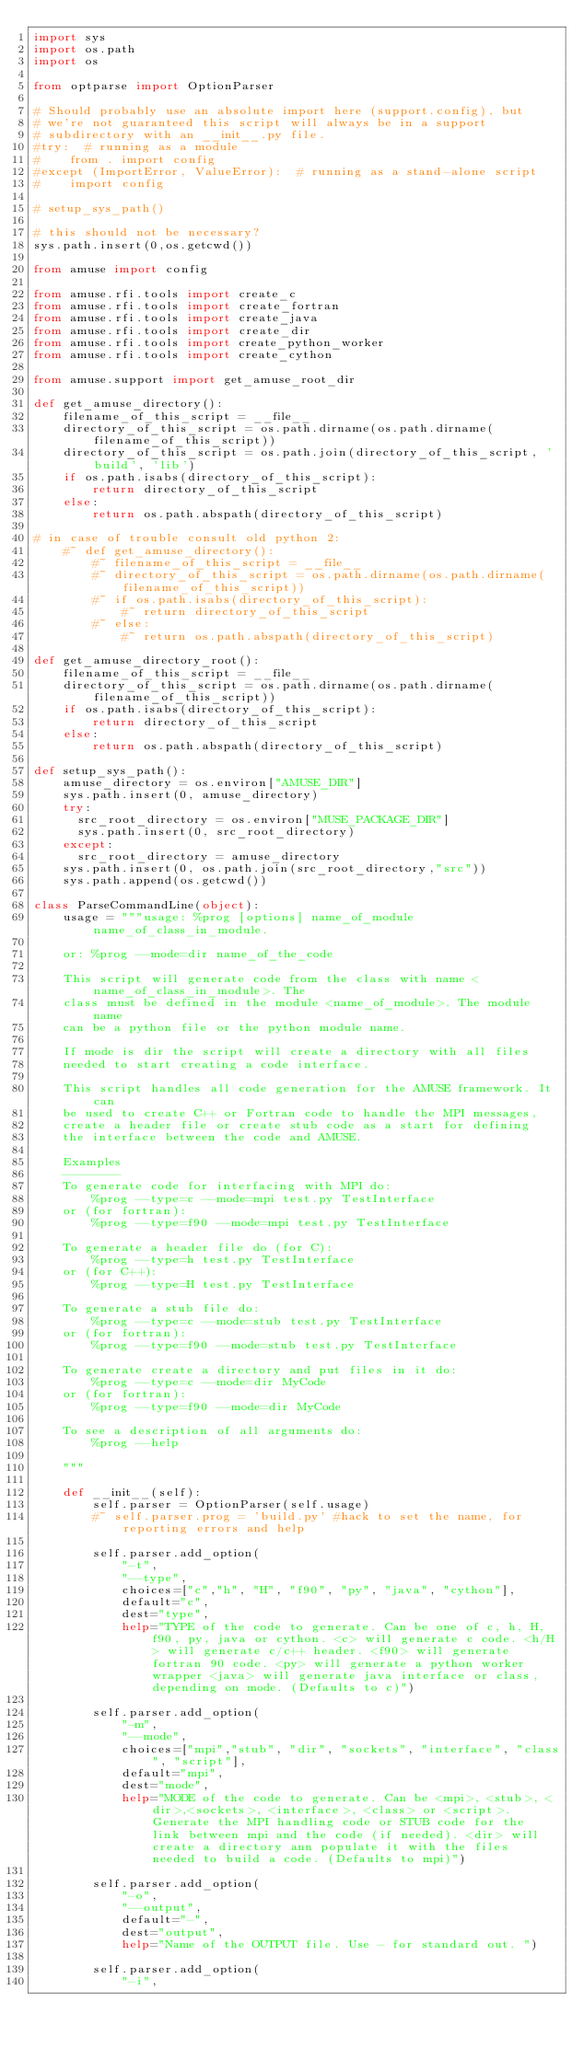Convert code to text. <code><loc_0><loc_0><loc_500><loc_500><_Python_>import sys
import os.path
import os

from optparse import OptionParser

# Should probably use an absolute import here (support.config), but
# we're not guaranteed this script will always be in a support
# subdirectory with an __init__.py file.
#try:  # running as a module
#    from . import config
#except (ImportError, ValueError):  # running as a stand-alone script
#    import config

# setup_sys_path()

# this should not be necessary?
sys.path.insert(0,os.getcwd())

from amuse import config

from amuse.rfi.tools import create_c
from amuse.rfi.tools import create_fortran
from amuse.rfi.tools import create_java
from amuse.rfi.tools import create_dir
from amuse.rfi.tools import create_python_worker
from amuse.rfi.tools import create_cython
    
from amuse.support import get_amuse_root_dir    

def get_amuse_directory():
    filename_of_this_script = __file__
    directory_of_this_script = os.path.dirname(os.path.dirname(filename_of_this_script))
    directory_of_this_script = os.path.join(directory_of_this_script, 'build', 'lib')
    if os.path.isabs(directory_of_this_script):
        return directory_of_this_script
    else:
        return os.path.abspath(directory_of_this_script)

# in case of trouble consult old python 2:     
    #~ def get_amuse_directory():
        #~ filename_of_this_script = __file__
        #~ directory_of_this_script = os.path.dirname(os.path.dirname(filename_of_this_script))
        #~ if os.path.isabs(directory_of_this_script):
            #~ return directory_of_this_script
        #~ else:
            #~ return os.path.abspath(directory_of_this_script)

def get_amuse_directory_root():
    filename_of_this_script = __file__
    directory_of_this_script = os.path.dirname(os.path.dirname(filename_of_this_script))
    if os.path.isabs(directory_of_this_script):
        return directory_of_this_script
    else:
        return os.path.abspath(directory_of_this_script)

def setup_sys_path():
    amuse_directory = os.environ["AMUSE_DIR"]
    sys.path.insert(0, amuse_directory)
    try:
      src_root_directory = os.environ["MUSE_PACKAGE_DIR"]
      sys.path.insert(0, src_root_directory)
    except:
      src_root_directory = amuse_directory
    sys.path.insert(0, os.path.join(src_root_directory,"src"))
    sys.path.append(os.getcwd())

class ParseCommandLine(object):
    usage = """usage: %prog [options] name_of_module name_of_class_in_module.
    
    or: %prog --mode=dir name_of_the_code
    
    This script will generate code from the class with name <name_of_class_in_module>. The
    class must be defined in the module <name_of_module>. The module name
    can be a python file or the python module name.
    
    If mode is dir the script will create a directory with all files
    needed to start creating a code interface.
    
    This script handles all code generation for the AMUSE framework. It can
    be used to create C++ or Fortran code to handle the MPI messages, 
    create a header file or create stub code as a start for defining
    the interface between the code and AMUSE.
    
    Examples
    --------
    To generate code for interfacing with MPI do:
        %prog --type=c --mode=mpi test.py TestInterface
    or (for fortran):
        %prog --type=f90 --mode=mpi test.py TestInterface
        
    To generate a header file do (for C):
        %prog --type=h test.py TestInterface
    or (for C++):
        %prog --type=H test.py TestInterface
        
    To generate a stub file do:
        %prog --type=c --mode=stub test.py TestInterface
    or (for fortran):
        %prog --type=f90 --mode=stub test.py TestInterface
        
    To generate create a directory and put files in it do:
        %prog --type=c --mode=dir MyCode
    or (for fortran):
        %prog --type=f90 --mode=dir MyCode
    
    To see a description of all arguments do:
        %prog --help
    
    """
    
    def __init__(self):
        self.parser = OptionParser(self.usage)
        #~ self.parser.prog = 'build.py' #hack to set the name, for reporting errors and help
        
        self.parser.add_option(
            "-t",
            "--type",
            choices=["c","h", "H", "f90", "py", "java", "cython"],
            default="c",
            dest="type",
            help="TYPE of the code to generate. Can be one of c, h, H, f90, py, java or cython. <c> will generate c code. <h/H> will generate c/c++ header. <f90> will generate fortran 90 code. <py> will generate a python worker wrapper <java> will generate java interface or class, depending on mode. (Defaults to c)")
        
        self.parser.add_option(
            "-m",
            "--mode",
            choices=["mpi","stub", "dir", "sockets", "interface", "class", "script"],
            default="mpi",
            dest="mode",
            help="MODE of the code to generate. Can be <mpi>, <stub>, <dir>,<sockets>, <interface>, <class> or <script>. Generate the MPI handling code or STUB code for the link between mpi and the code (if needed). <dir> will create a directory ann populate it with the files needed to build a code. (Defaults to mpi)")
        
        self.parser.add_option(
            "-o",
            "--output",
            default="-",
            dest="output",
            help="Name of the OUTPUT file. Use - for standard out. ")
        
        self.parser.add_option(
            "-i",</code> 